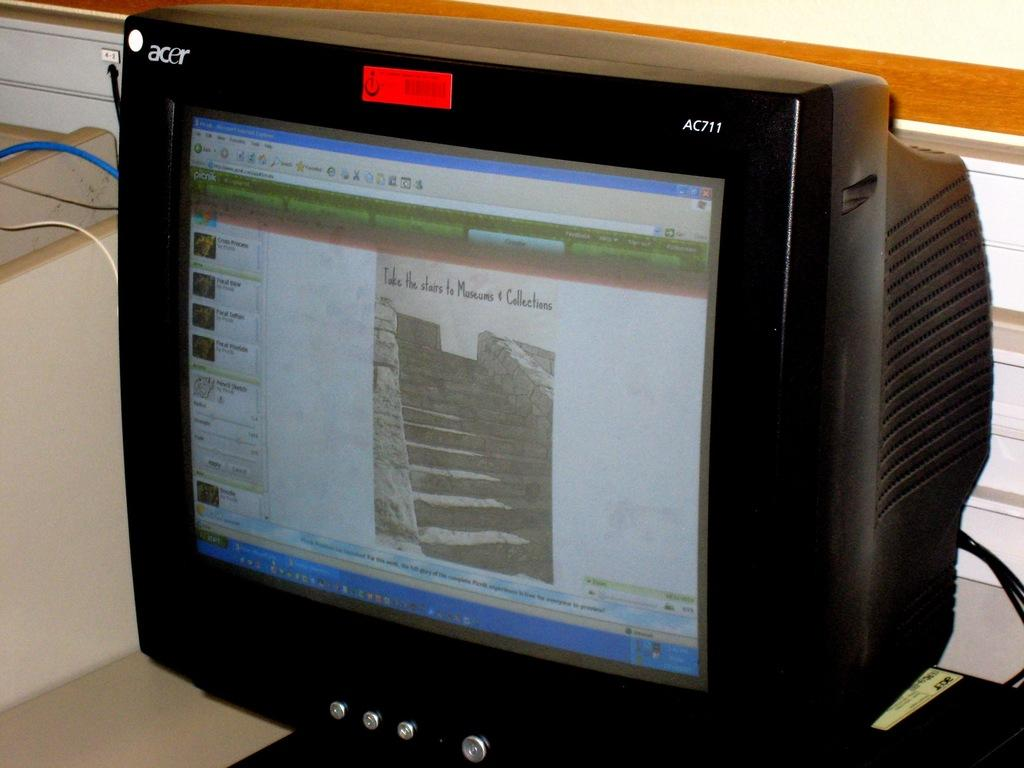<image>
Summarize the visual content of the image. A computer monitor that is on the website picnik. 